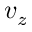Convert formula to latex. <formula><loc_0><loc_0><loc_500><loc_500>v _ { z }</formula> 